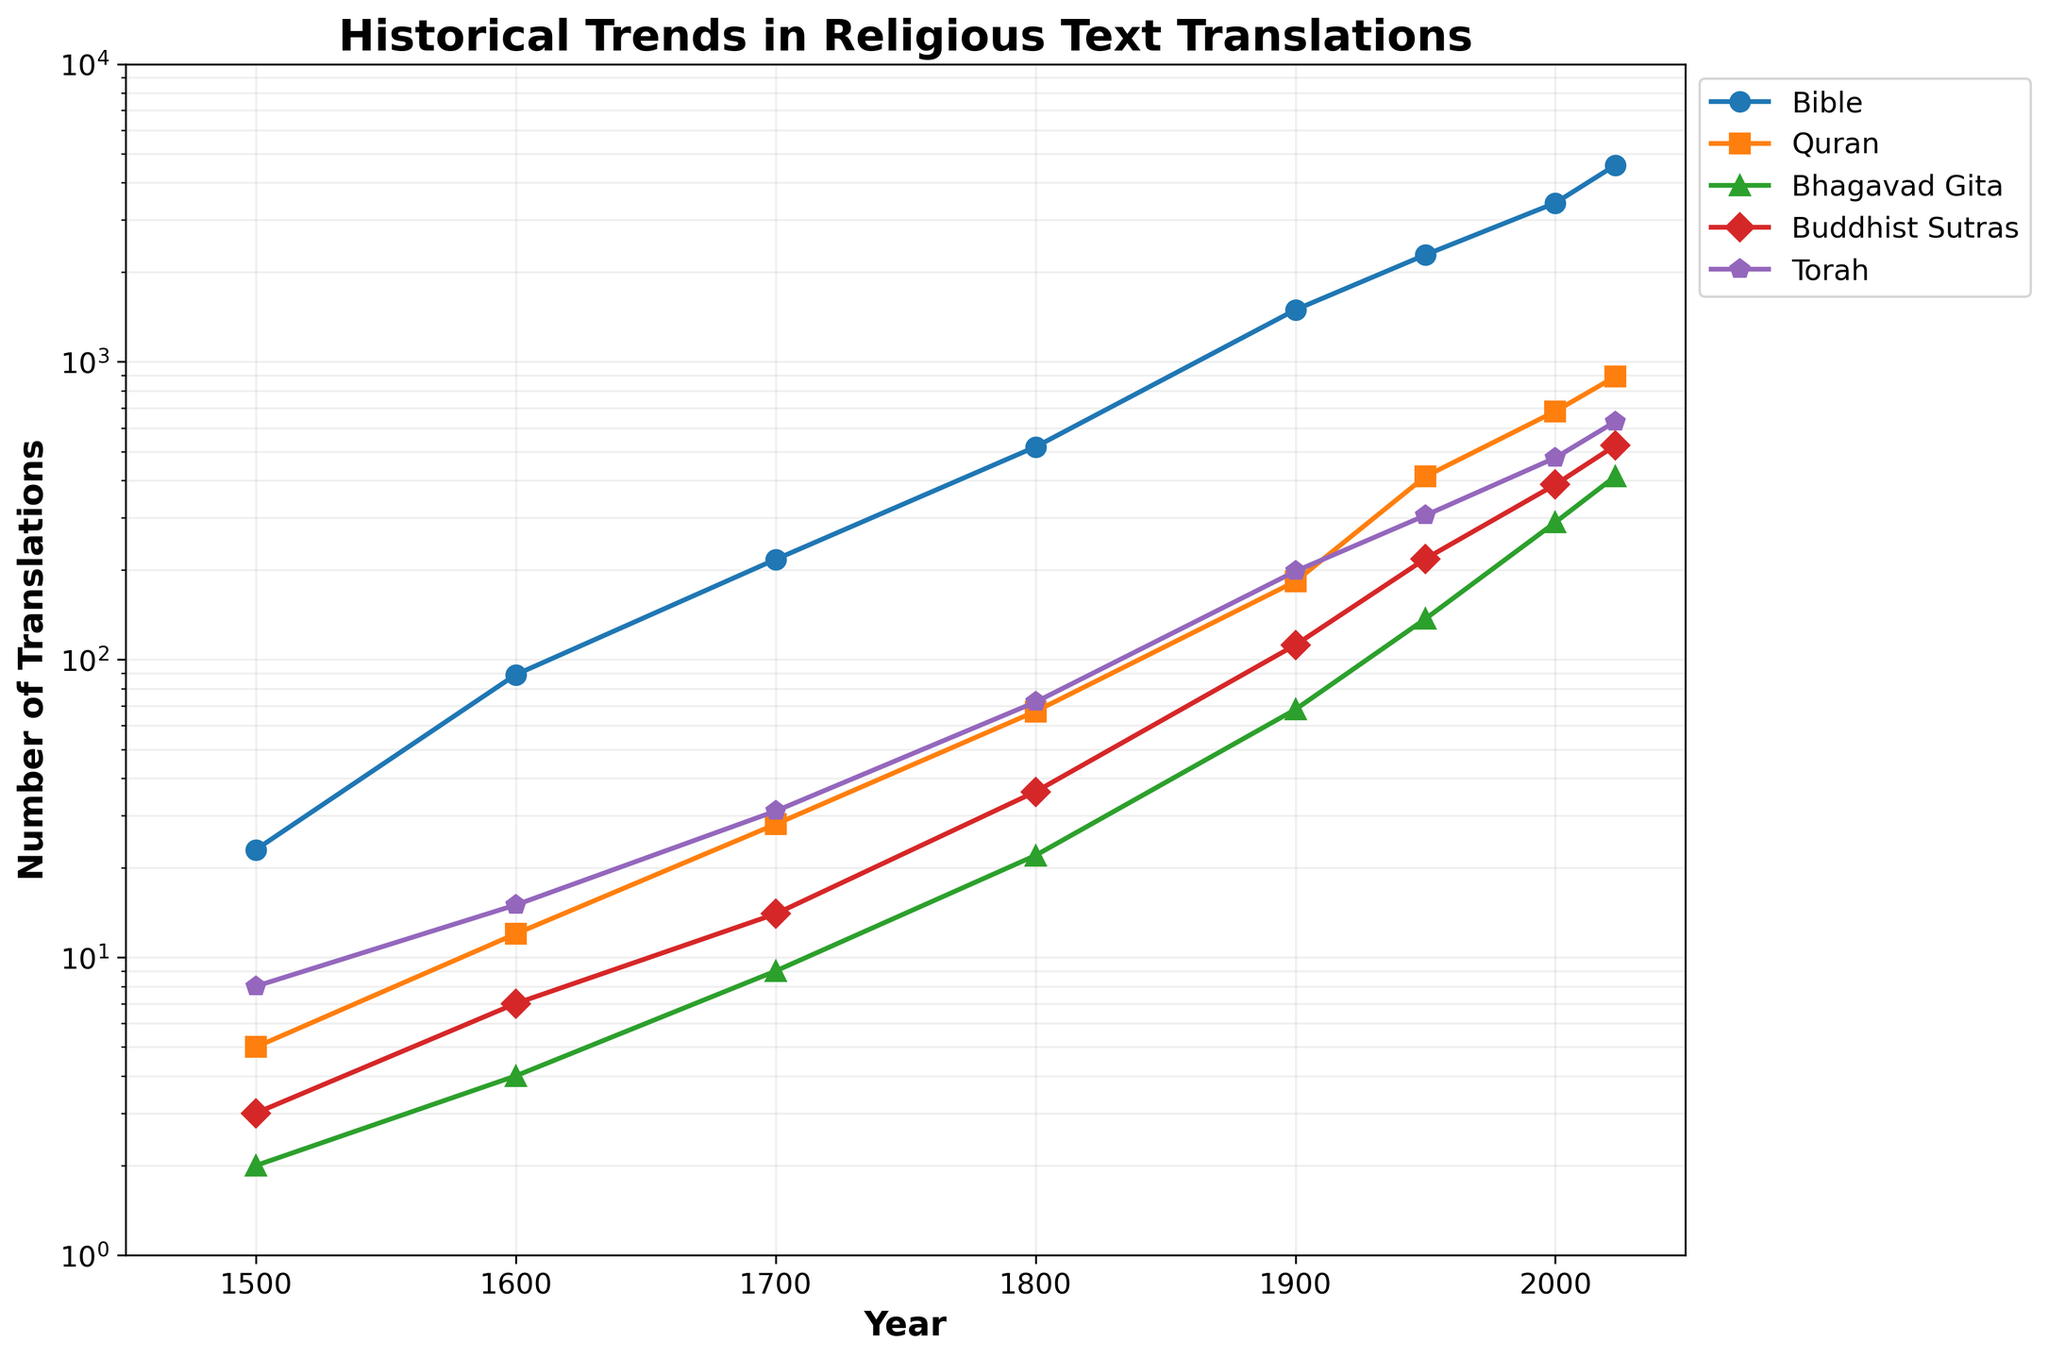How many more translations of the Bible were there in the year 2023 compared to the year 1600? To find the difference, subtract the number of translations in 1600 from the number of translations in 2023: 4569 - 89 = 4480
Answer: 4480 Which religious text had the highest number of translations in 1900? By examining the data points for 1900, we can see that the Bible had the highest number of translations at 1495
Answer: Bible What is the trend in the number of Torah translations from 1800 to 2023? Observe the Torah translations data from 1800 (72), 1900 (198), 1950 (305), 2000 (476), and 2023 (629). The number consistently increases over time.
Answer: Increasing Which religion saw the slowest growth in translations between 2000 and 2023? Compare the difference in translations between 2000 and 2023 for all texts: Bible (4569-3415=1154), Quran (891-682=209), Bhagavad Gita (412-289=123), Buddhist Sutras (523-387=136), Torah (629-476=153). The Bhagavad Gita has the smallest increase of 123.
Answer: Bhagavad Gita By what factor did the number of Buddhist Sutras translations grow from 1500 to 2000? Divide the number of translations in 2000 by the number in 1500: 387 / 3 = 129
Answer: 129 What can be inferred from the visual trend of the Bible translations line compared to the other religious texts? The Bible consistently has the highest number of translations and shows a steeper upward trend compared to the other texts, indicating a faster rate of increase.
Answer: Higher rate of increase Between 1800 and 1900, which religious text had the largest absolute increase in the number of translations? Calculate the difference between 1800 and 1900 for each text: Bible (1495-518=977), Quran (183-67=116), Bhagavad Gita (68-22=46), Buddhist Sutras (112-36=76), Torah (198-72=126). The Bible has the largest absolute increase
Answer: Bible In what year did the number of Quran translations first exceed 500? By examining the data points for the Quran, we see that it exceeded 500 translations in the year 2000 with 682 translations.
Answer: 2000 What is the average number of translations for the Bhagavad Gita over the given years? Sum the number of translations for all given years and then divide by 8 (number of data points): (2+4+9+22+68+137+289+412)/8 = 117.875
Answer: 117.875 Among all the religious texts, which one showed the most rapid growth after 1950? Compare the increase in translations from 1950 to 2000: Bible (3415-2287=1128), Quran (682-412=270), Bhagavad Gita (289-137=152), Buddhist Sutras (387-218=169), Torah (476-305=171). The Bible showed the most rapid growth.
Answer: Bible 